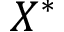<formula> <loc_0><loc_0><loc_500><loc_500>X ^ { * }</formula> 